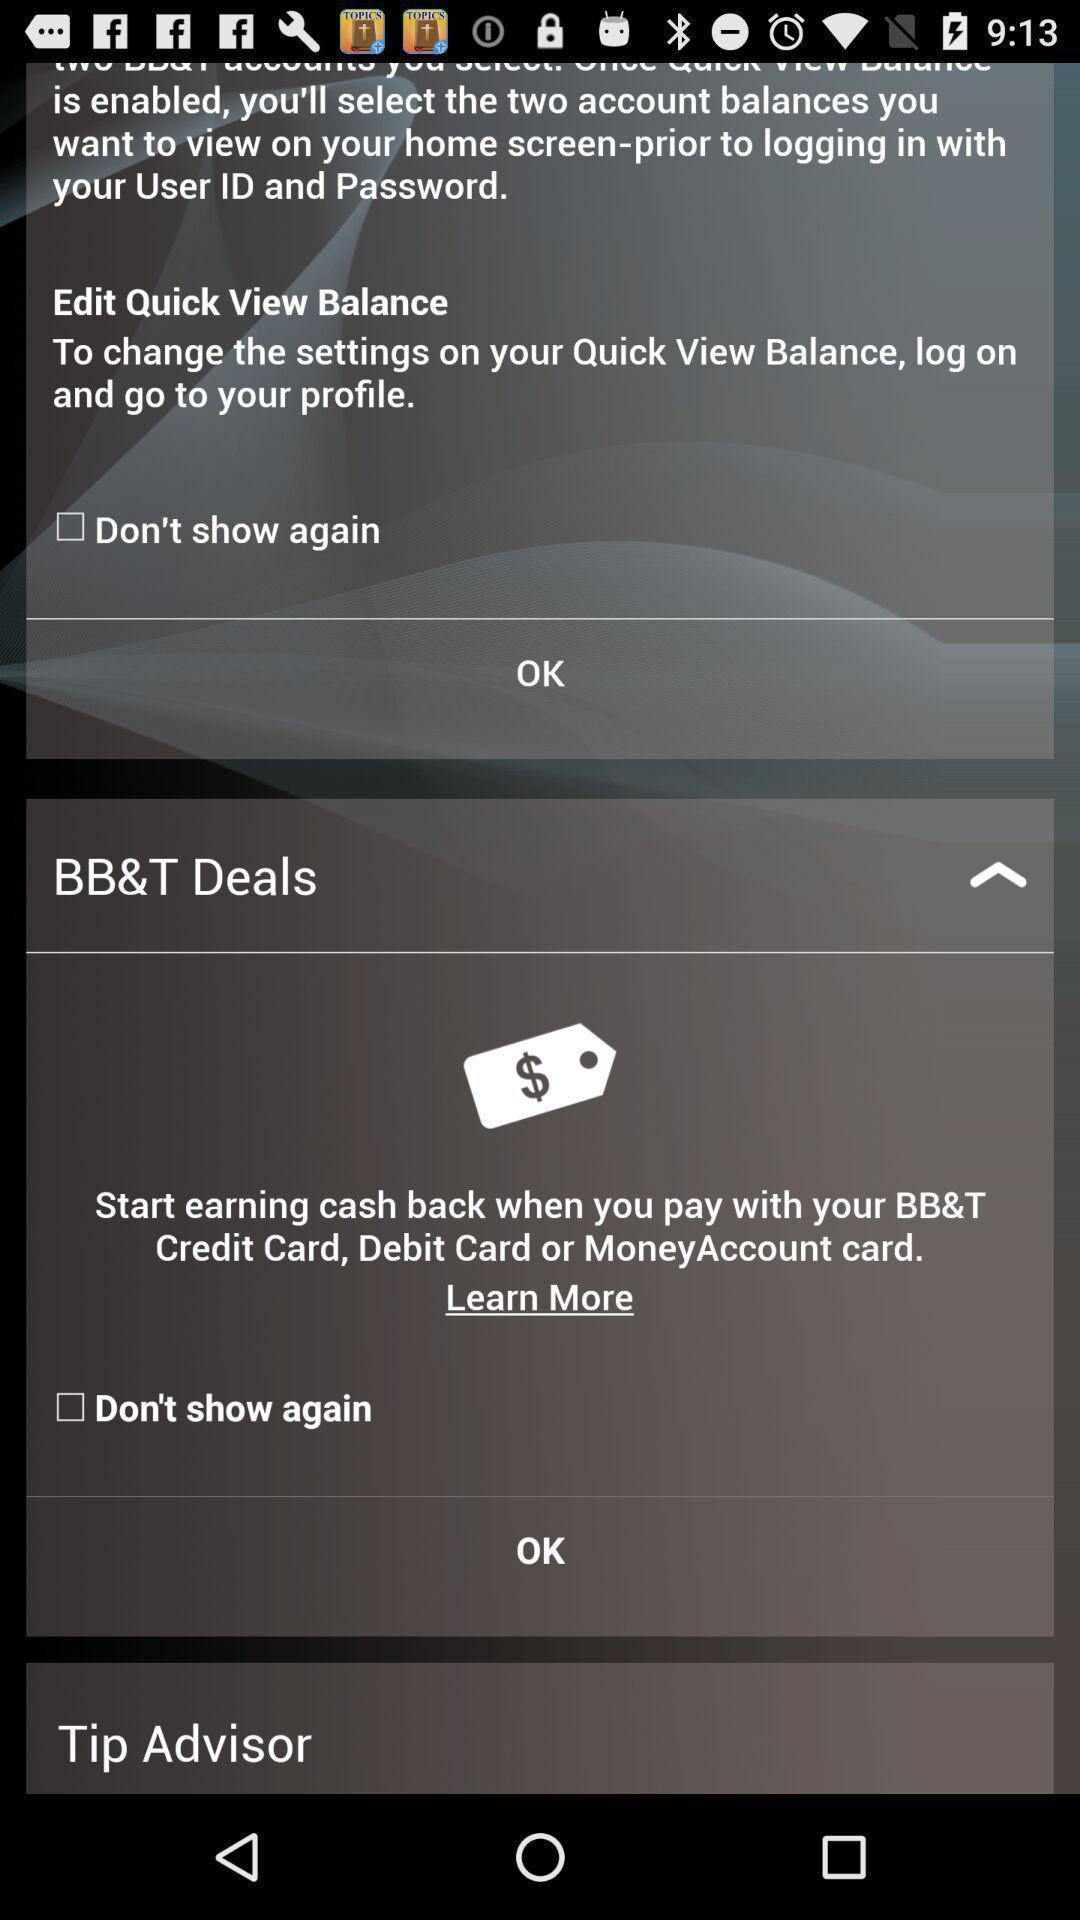What details can you identify in this image? Screen showing information about app. 